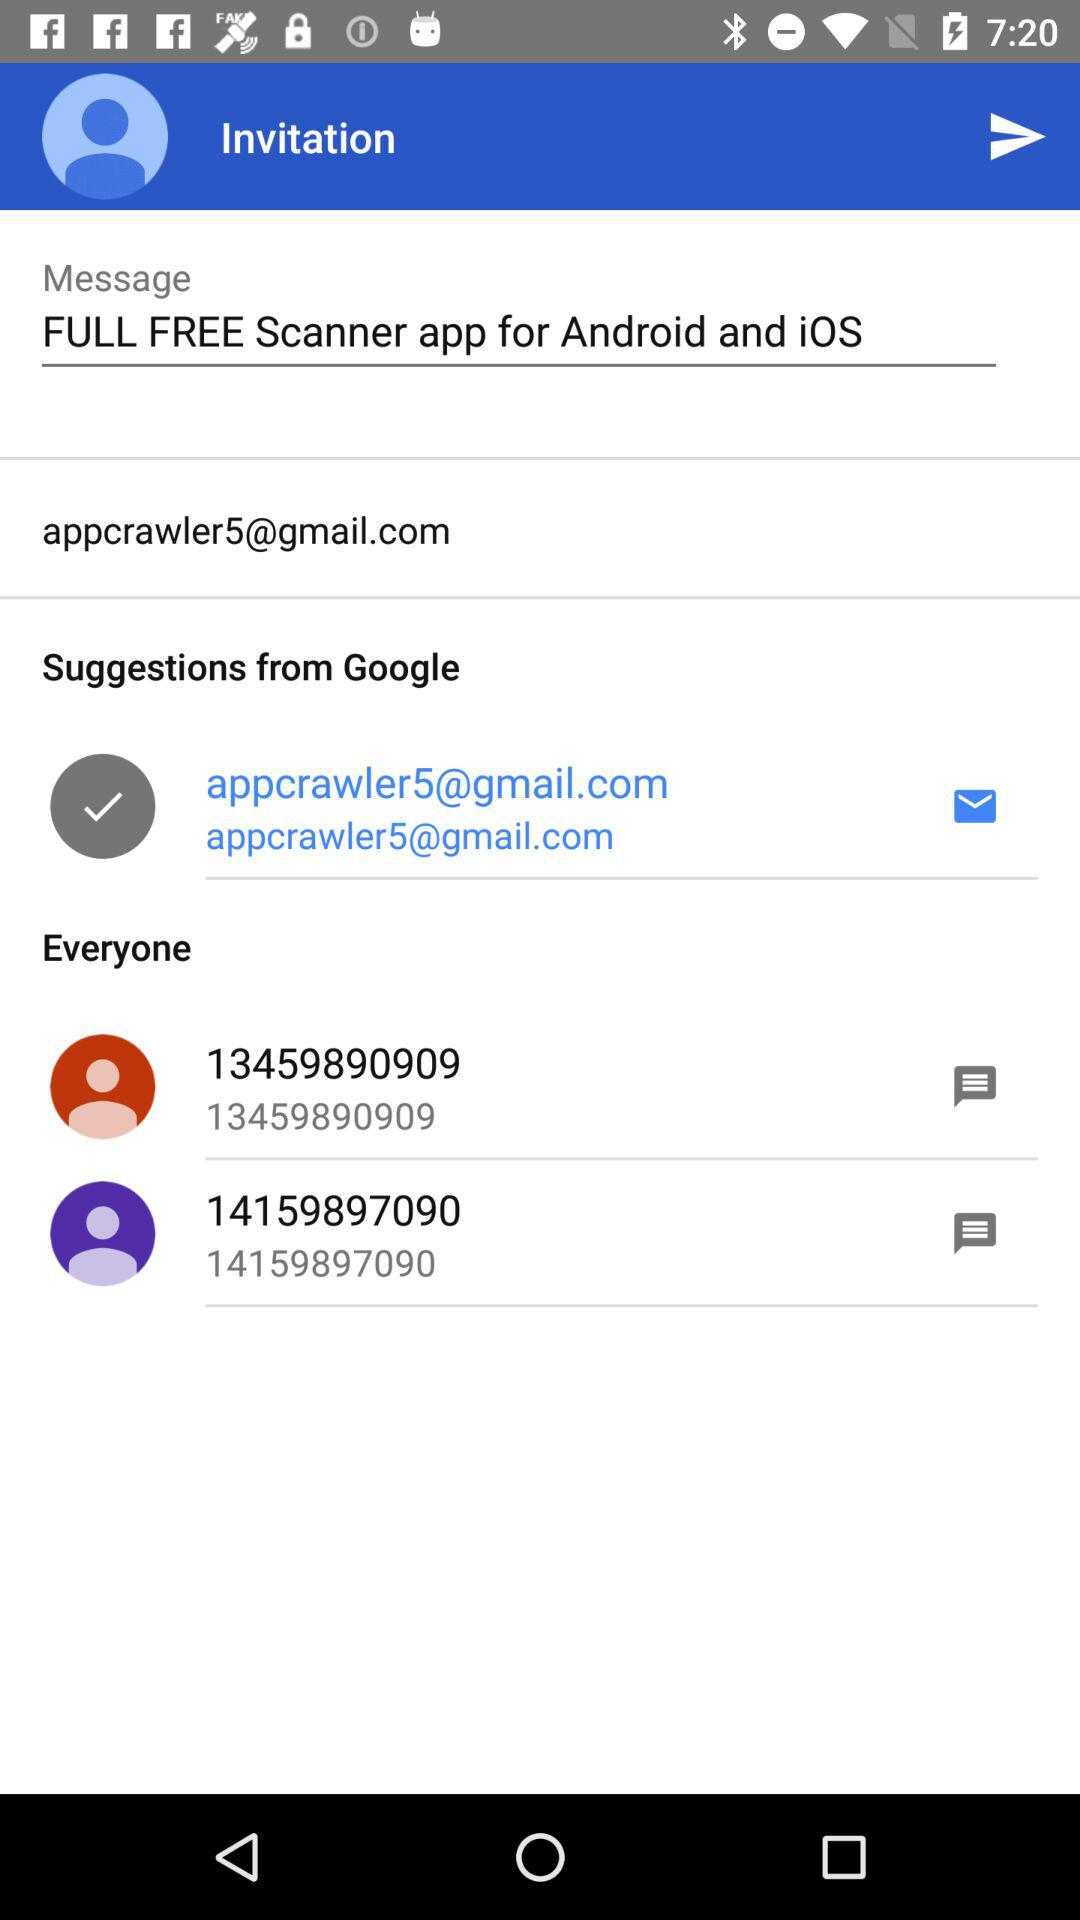What is the message? The message is "FULL FREE Scanner app for Android and iOS". 